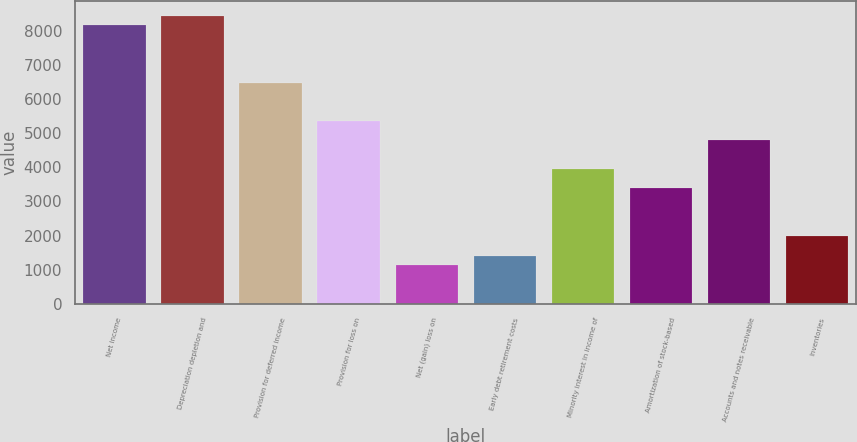Convert chart. <chart><loc_0><loc_0><loc_500><loc_500><bar_chart><fcel>Net income<fcel>Depreciation depletion and<fcel>Provision for deferred income<fcel>Provision for loss on<fcel>Net (gain) loss on<fcel>Early debt retirement costs<fcel>Minority interest in income of<fcel>Amortization of stock-based<fcel>Accounts and notes receivable<fcel>Inventories<nl><fcel>8160.7<fcel>8442<fcel>6472.9<fcel>5347.7<fcel>1128.2<fcel>1409.5<fcel>3941.2<fcel>3378.6<fcel>4785.1<fcel>1972.1<nl></chart> 